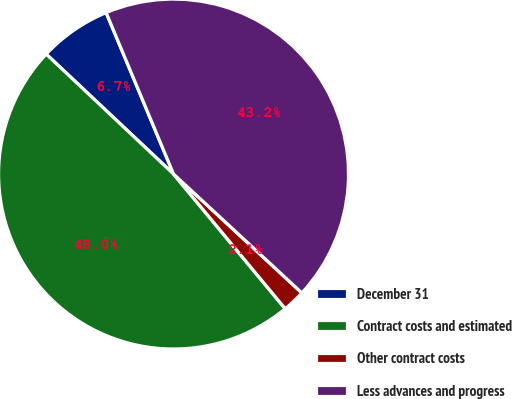Convert chart to OTSL. <chart><loc_0><loc_0><loc_500><loc_500><pie_chart><fcel>December 31<fcel>Contract costs and estimated<fcel>Other contract costs<fcel>Less advances and progress<nl><fcel>6.68%<fcel>48.04%<fcel>2.09%<fcel>43.19%<nl></chart> 